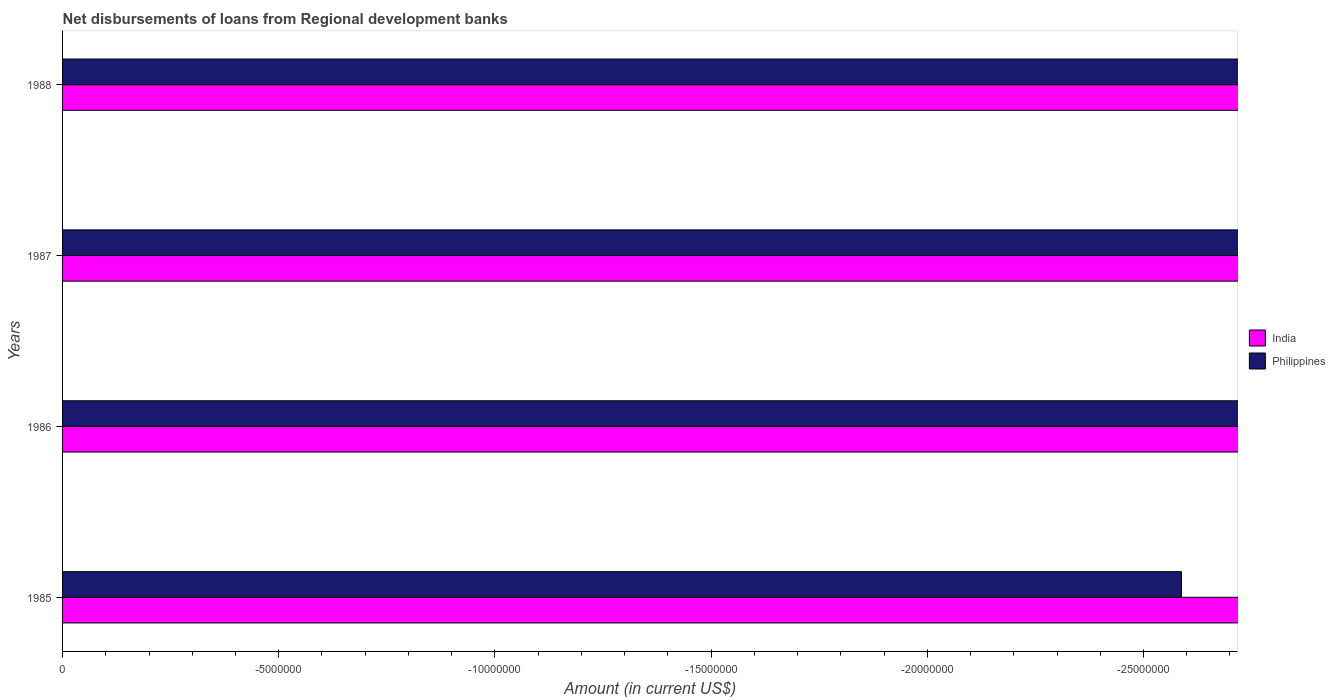Are the number of bars on each tick of the Y-axis equal?
Offer a terse response. Yes. How many bars are there on the 2nd tick from the top?
Ensure brevity in your answer.  0. What is the label of the 1st group of bars from the top?
Your response must be concise. 1988. What is the amount of disbursements of loans from regional development banks in Philippines in 1988?
Offer a terse response. 0. Across all years, what is the minimum amount of disbursements of loans from regional development banks in Philippines?
Your response must be concise. 0. What is the average amount of disbursements of loans from regional development banks in Philippines per year?
Ensure brevity in your answer.  0. In how many years, is the amount of disbursements of loans from regional development banks in Philippines greater than -11000000 US$?
Give a very brief answer. 0. How many bars are there?
Your answer should be compact. 0. How many years are there in the graph?
Offer a terse response. 4. Does the graph contain grids?
Provide a short and direct response. No. How many legend labels are there?
Make the answer very short. 2. What is the title of the graph?
Your answer should be compact. Net disbursements of loans from Regional development banks. What is the label or title of the Y-axis?
Provide a succinct answer. Years. What is the Amount (in current US$) in India in 1985?
Offer a very short reply. 0. What is the Amount (in current US$) of Philippines in 1985?
Your answer should be compact. 0. What is the Amount (in current US$) in India in 1986?
Your answer should be very brief. 0. What is the Amount (in current US$) in India in 1987?
Provide a short and direct response. 0. What is the Amount (in current US$) in Philippines in 1987?
Make the answer very short. 0. What is the average Amount (in current US$) in India per year?
Provide a short and direct response. 0. What is the average Amount (in current US$) of Philippines per year?
Provide a short and direct response. 0. 